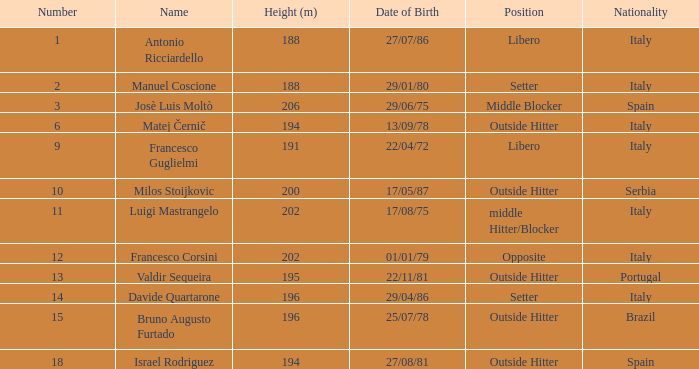Name the height for date of birth being 17/08/75 202.0. Would you be able to parse every entry in this table? {'header': ['Number', 'Name', 'Height (m)', 'Date of Birth', 'Position', 'Nationality'], 'rows': [['1', 'Antonio Ricciardello', '188', '27/07/86', 'Libero', 'Italy'], ['2', 'Manuel Coscione', '188', '29/01/80', 'Setter', 'Italy'], ['3', 'Josè Luis Moltò', '206', '29/06/75', 'Middle Blocker', 'Spain'], ['6', 'Matej Černič', '194', '13/09/78', 'Outside Hitter', 'Italy'], ['9', 'Francesco Guglielmi', '191', '22/04/72', 'Libero', 'Italy'], ['10', 'Milos Stoijkovic', '200', '17/05/87', 'Outside Hitter', 'Serbia'], ['11', 'Luigi Mastrangelo', '202', '17/08/75', 'middle Hitter/Blocker', 'Italy'], ['12', 'Francesco Corsini', '202', '01/01/79', 'Opposite', 'Italy'], ['13', 'Valdir Sequeira', '195', '22/11/81', 'Outside Hitter', 'Portugal'], ['14', 'Davide Quartarone', '196', '29/04/86', 'Setter', 'Italy'], ['15', 'Bruno Augusto Furtado', '196', '25/07/78', 'Outside Hitter', 'Brazil'], ['18', 'Israel Rodriguez', '194', '27/08/81', 'Outside Hitter', 'Spain']]} 